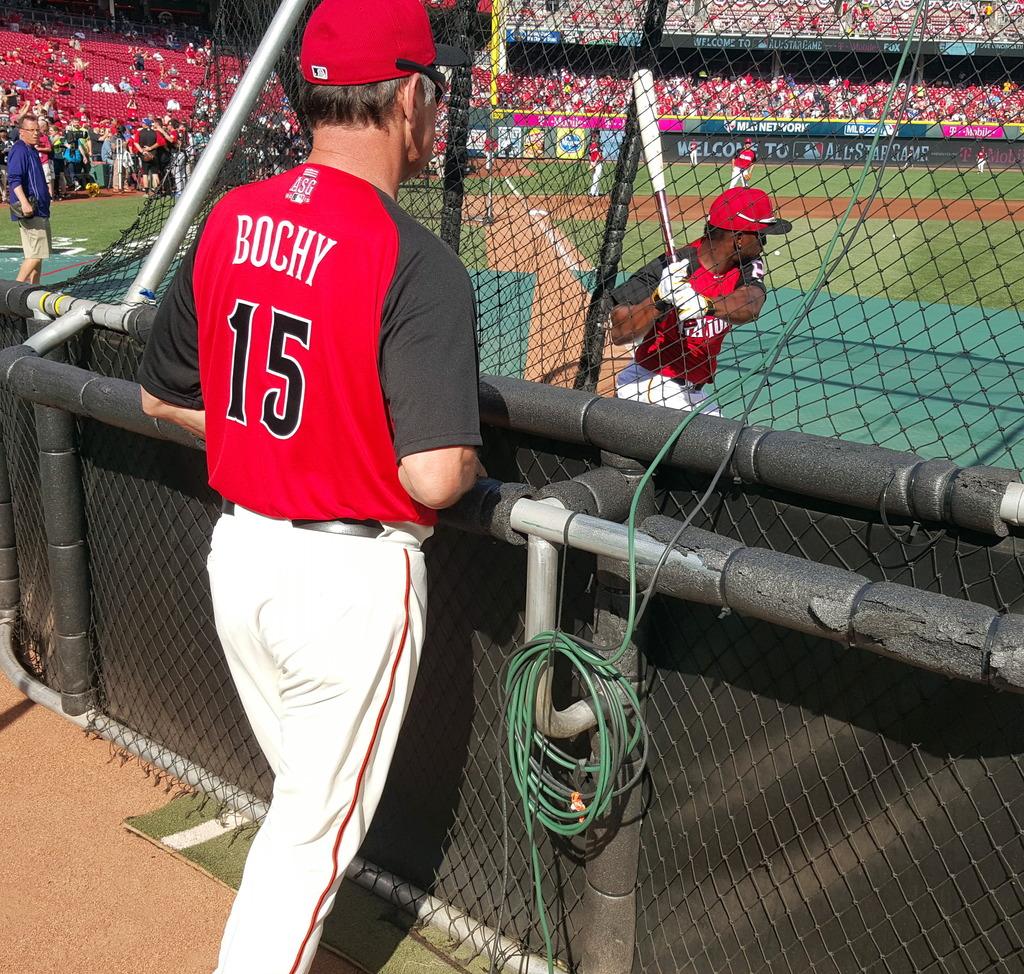What is the sign in the back welcoming you to?
Offer a terse response. Unanswerable. 